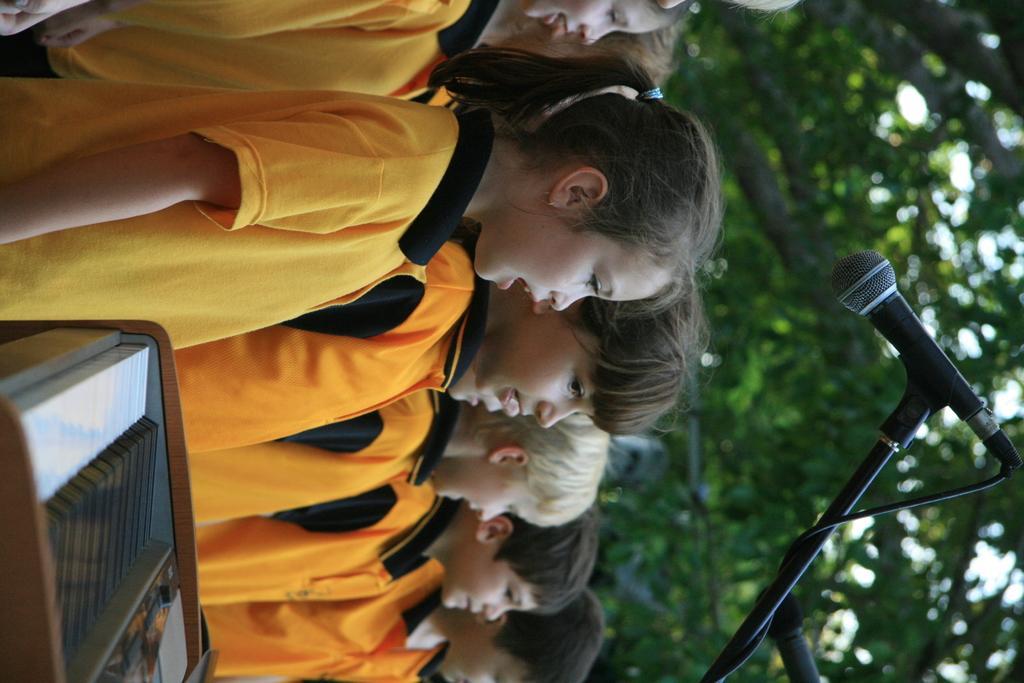Can you describe this image briefly? In this image I can see the group of people with black, orange and yellow color dresses. I can see the musical instrument in-front of few people. To the right I can see the mic with stand. In the background I can see the trees. 